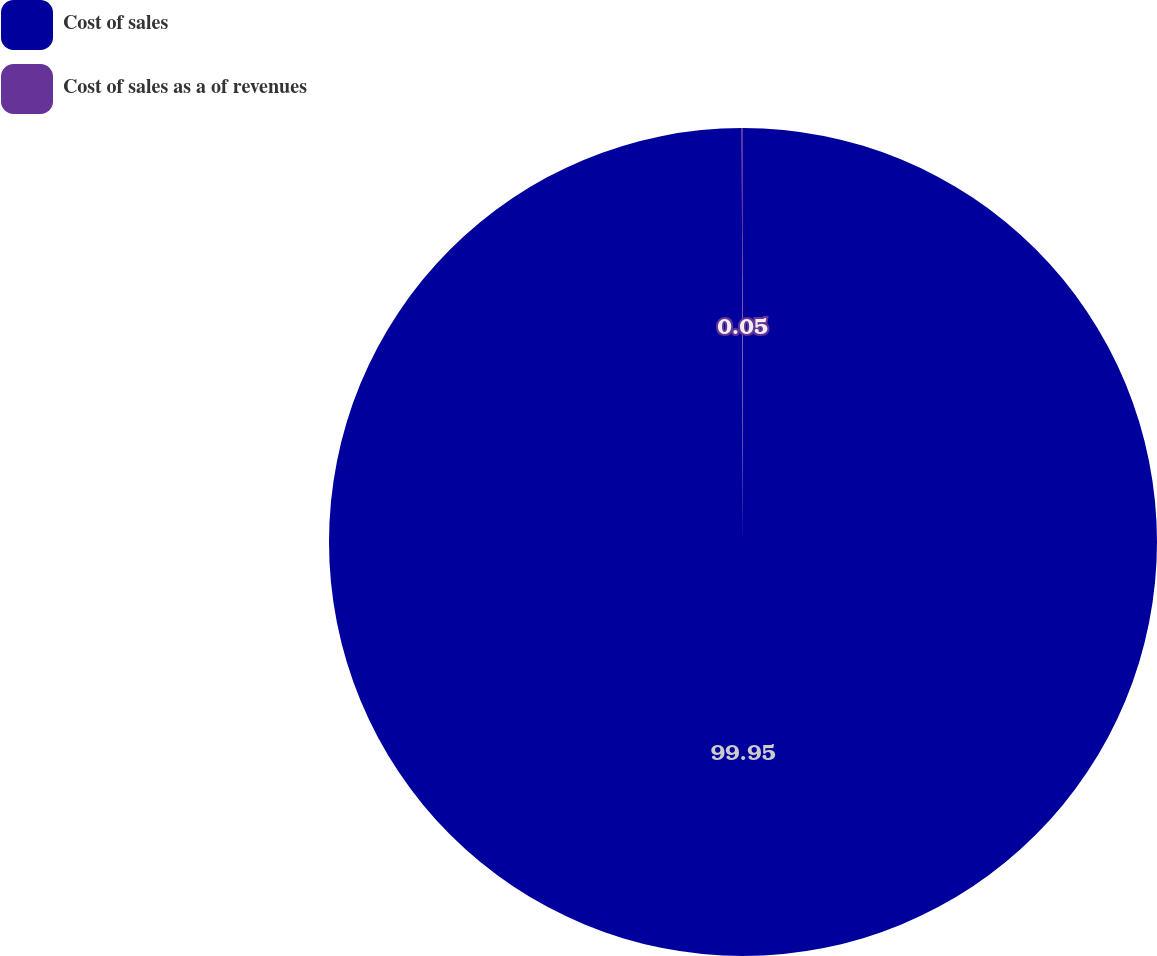Convert chart. <chart><loc_0><loc_0><loc_500><loc_500><pie_chart><fcel>Cost of sales<fcel>Cost of sales as a of revenues<nl><fcel>99.95%<fcel>0.05%<nl></chart> 